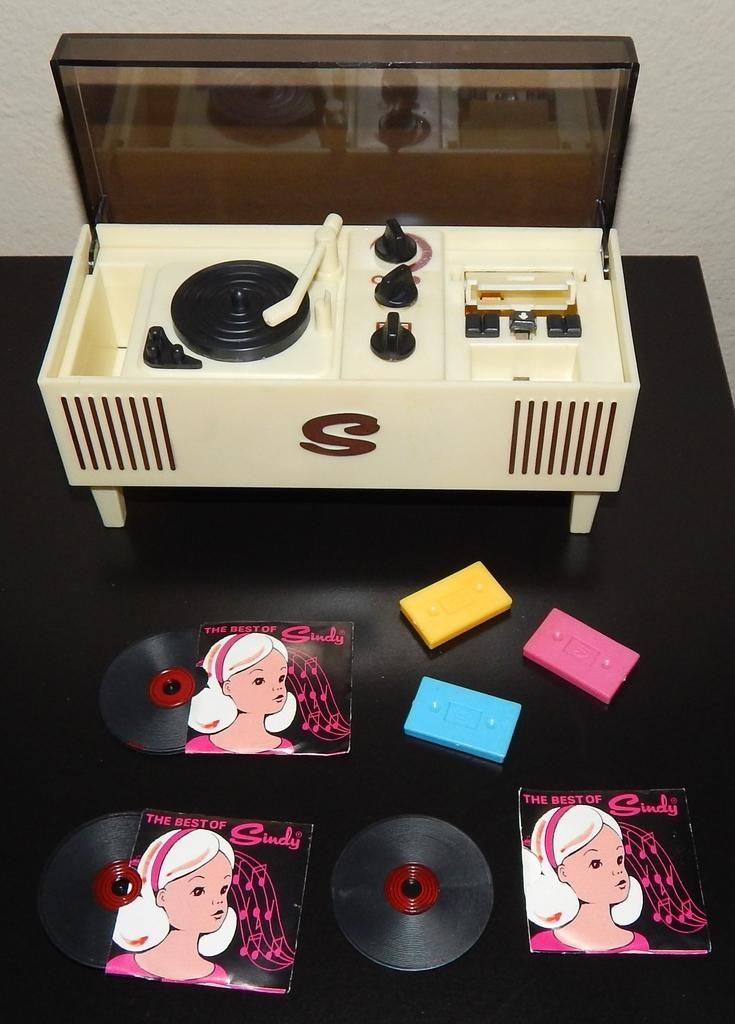<image>
Relay a brief, clear account of the picture shown. A child's record player has a large S on the front. 